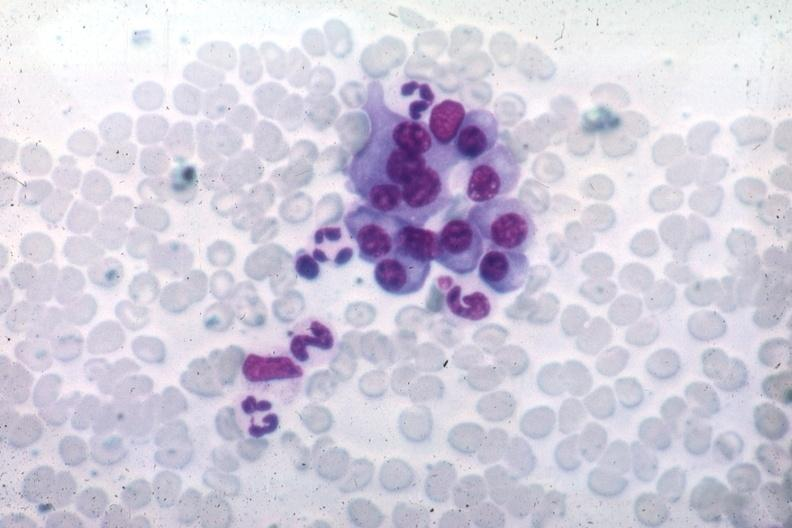what is present?
Answer the question using a single word or phrase. Plasma cell 